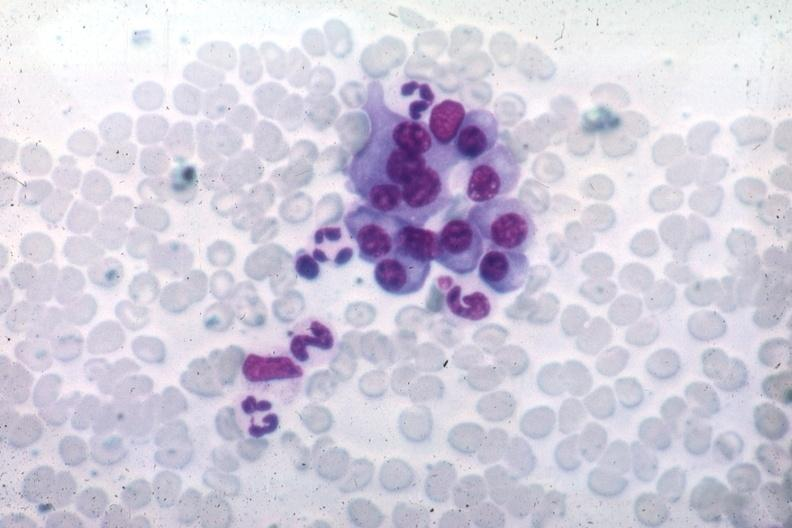what is present?
Answer the question using a single word or phrase. Plasma cell 